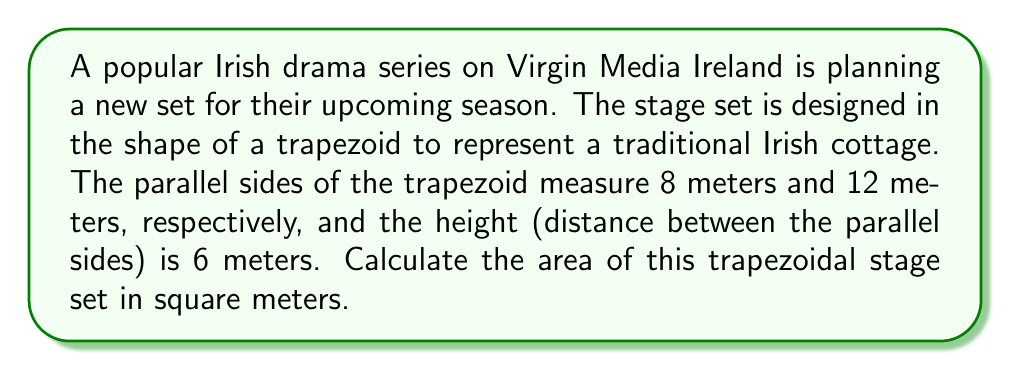Help me with this question. Let's approach this step-by-step:

1) The formula for the area of a trapezoid is:

   $$A = \frac{1}{2}(b_1 + b_2)h$$

   where $A$ is the area, $b_1$ and $b_2$ are the lengths of the parallel sides, and $h$ is the height.

2) We are given:
   - $b_1 = 8$ meters
   - $b_2 = 12$ meters
   - $h = 6$ meters

3) Let's substitute these values into the formula:

   $$A = \frac{1}{2}(8 + 12) \cdot 6$$

4) First, let's add the parallel sides:

   $$A = \frac{1}{2}(20) \cdot 6$$

5) Now, multiply:

   $$A = 10 \cdot 6 = 60$$

Therefore, the area of the trapezoidal stage set is 60 square meters.

[asy]
unitsize(0.5cm);
pair A = (0,0), B = (12,0), C = (9,6), D = (-3,6);
draw(A--B--C--D--cycle);
draw((-3,0)--(9,0),dashed);
label("8m", (D--C),N);
label("12m", (A--B),S);
label("6m", (0,0)--(0,6),W);
[/asy]
Answer: 60 m² 